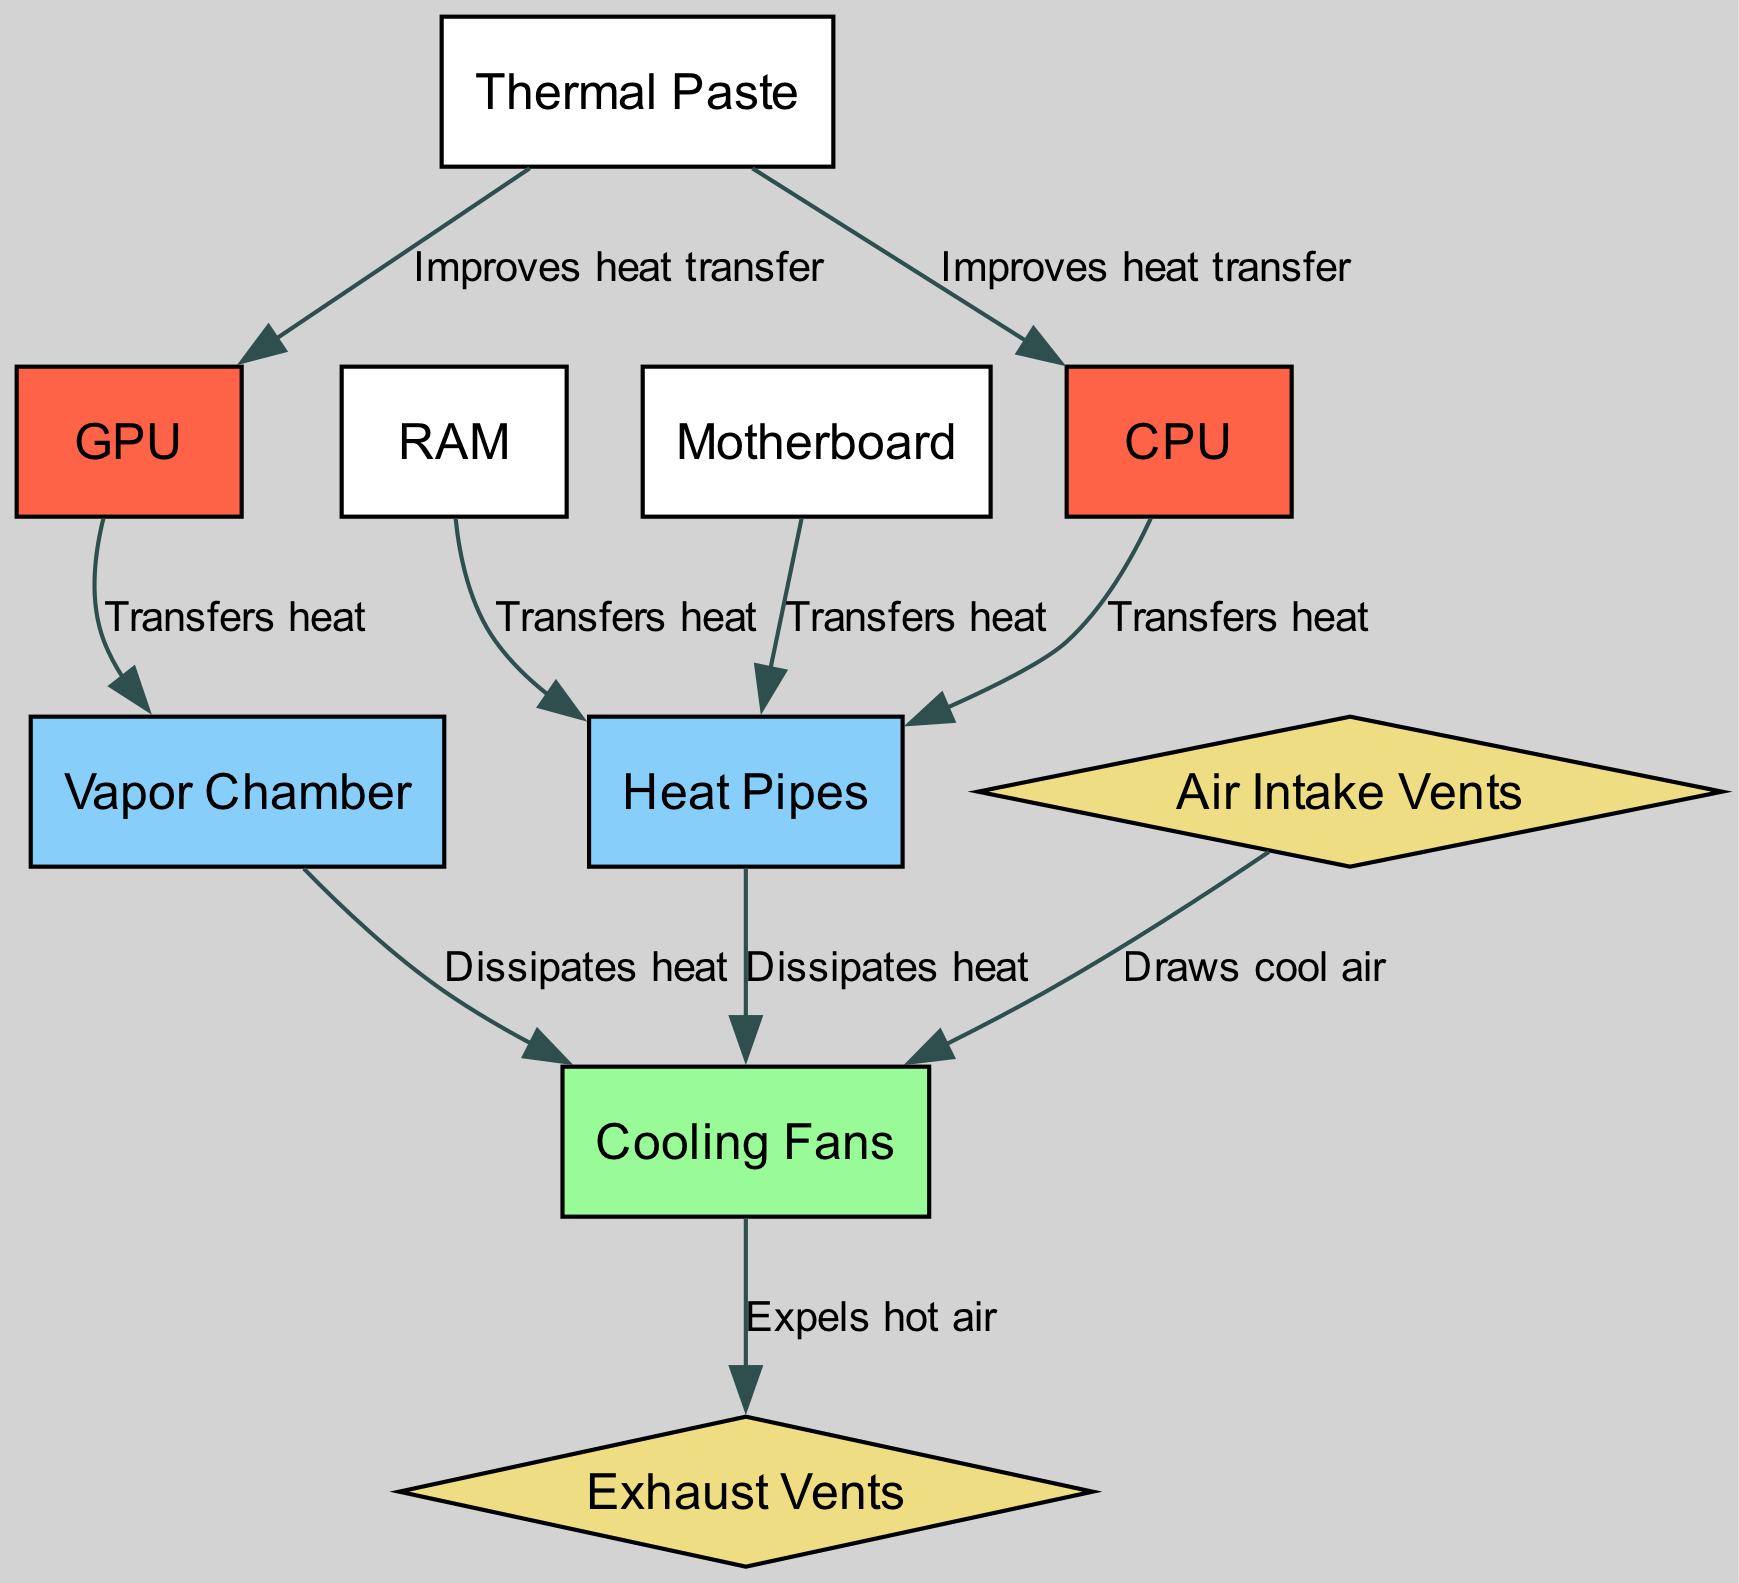What nodes are responsible for transferring heat? According to the diagram, the nodes that are indicated to transfer heat are the CPU, GPU, RAM, and Motherboard. Each of these components is connected to either Heat Pipes or a Vapor Chamber, illustrating their role in heat transfer.
Answer: CPU, GPU, RAM, Motherboard How many heat sources are shown in the diagram? By inspecting the diagram, the heat sources are the CPU, GPU, RAM, and Motherboard, which means there are four distinct sources contributing to heat generation within the system.
Answer: 4 What component dissipates heat from the Heat Pipes? The diagram shows that the Cooling Fans dissipate heat from the Heat Pipes. There is a direct edge labeled "Dissipates heat" connecting Heat Pipes to Cooling Fans that indicates this relationship.
Answer: Cooling Fans What is connected to Cooling Fans apart from Heat Pipes? In addition to Heat Pipes, the other component connected to Cooling Fans is the Vapor Chamber. The diagram displays edges from both Heat Pipes and Vapor Chamber to Cooling Fans, both labeled for heat dissipation.
Answer: Vapor Chamber What do Air Intake Vents do? According to the diagram, Air Intake Vents draw cool air into the cooling system. The edge from Air Intake Vents to Cooling Fans is labeled "Draws cool air," indicating this function within the thermal management system.
Answer: Draws cool air Which component improves heat transfer for both CPU and GPU? The Thermal Paste is the component that improves heat transfer for both the CPU and GPU, as indicated by the edges connecting Thermal Paste to these two heat sources in the diagram, both labeled "Improves heat transfer."
Answer: Thermal Paste What is the final destination of the hot air expelled by the Cooling Fans? The diagram shows that the Exhaust Vents are the final destination of the hot air expelled by the Cooling Fans, as indicated by the edge labeled "Expels hot air" connecting Cooling Fans to Exhaust Vents.
Answer: Exhaust Vents What two components are adjacent to Cooling Fans in the diagram? In the diagram, Cooling Fans are adjacent to Heat Pipes and Vapor Chamber, as they are directly linked to these components through edges representing heat dissipation from both.
Answer: Heat Pipes, Vapor Chamber How many edges are present in this diagram? By counting the connections (edges) in the diagram, there are a total of ten edges that represent the interactions and heat transfer pathways between different components of the thermal management system.
Answer: 10 